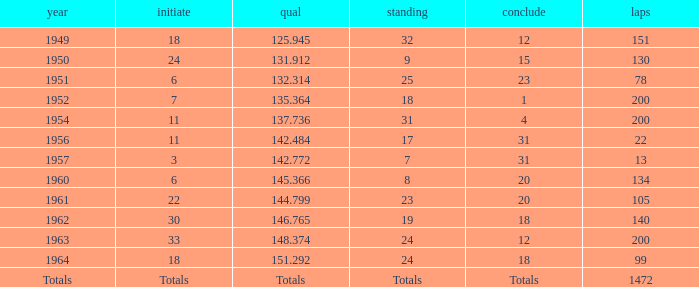Name the rank with laps of 200 and qual of 148.374 24.0. 